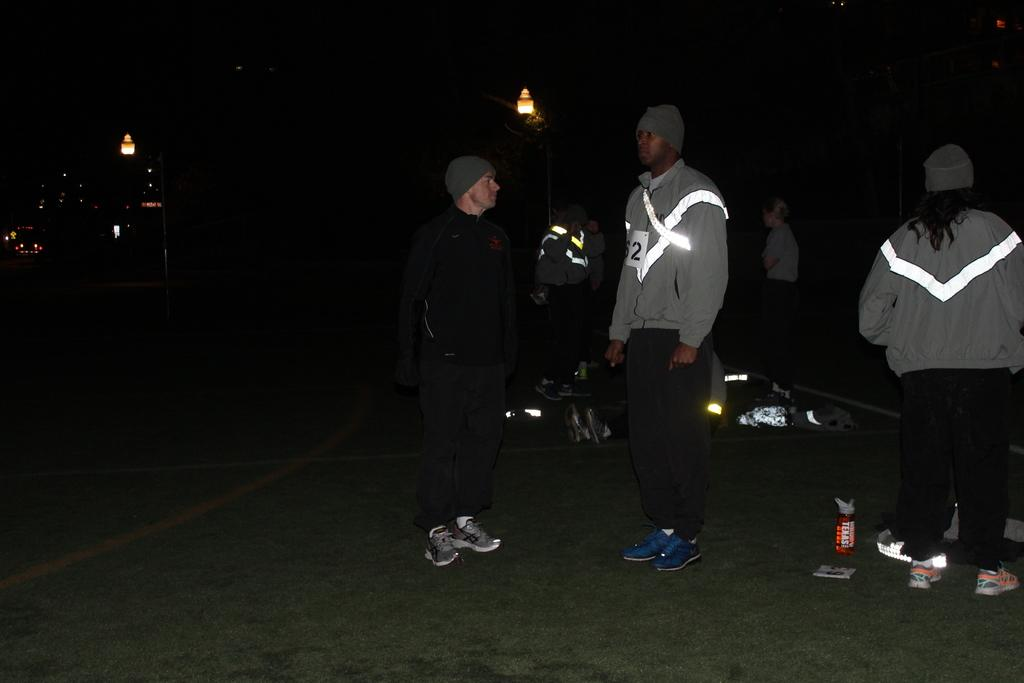How many people are in the image? There is a group of people in the image. What are the people wearing on their heads? The people are wearing caps. What type of footwear are the people wearing? The people are wearing shoes. Where are the people standing? The people are standing on the ground. What can be seen in the image that provides illumination? There are lights visible in the image. What else can be seen in the image besides the people? There are some objects in the image. How would you describe the overall lighting condition in the image? The background of the image is dark. What type of leather is being used to make the pizzas in the image? There are no pizzas present in the image, so it is not possible to determine the type of leather used in their production. 